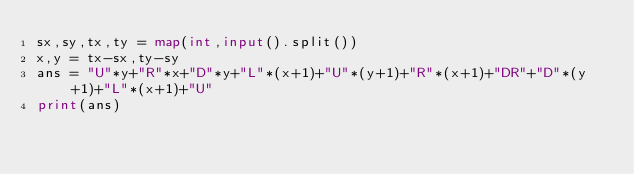<code> <loc_0><loc_0><loc_500><loc_500><_Python_>sx,sy,tx,ty = map(int,input().split())
x,y = tx-sx,ty-sy
ans = "U"*y+"R"*x+"D"*y+"L"*(x+1)+"U"*(y+1)+"R"*(x+1)+"DR"+"D"*(y+1)+"L"*(x+1)+"U"
print(ans)</code> 